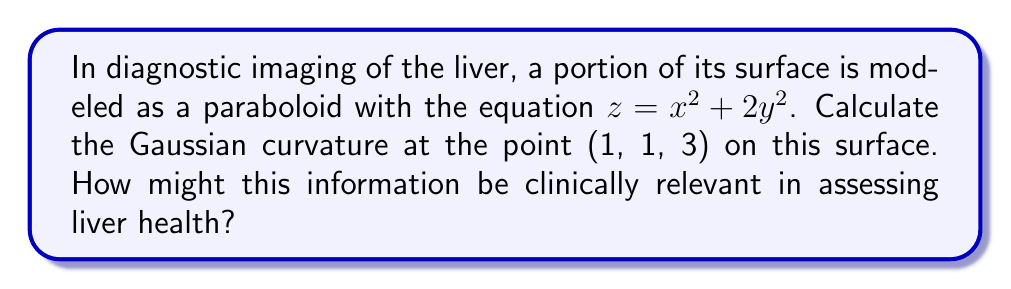Can you solve this math problem? To compute the Gaussian curvature of the liver surface modeled by $z = x^2 + 2y^2$ at the point (1, 1, 3), we'll follow these steps:

1) First, we need to calculate the first and second partial derivatives:
   $f_x = 2x$, $f_y = 4y$
   $f_{xx} = 2$, $f_{yy} = 4$, $f_{xy} = f_{yx} = 0$

2) Next, we compute the coefficients of the first fundamental form:
   $E = 1 + f_x^2 = 1 + 4x^2$
   $F = f_x f_y = 8xy$
   $G = 1 + f_y^2 = 1 + 16y^2$

3) Then, we calculate the coefficients of the second fundamental form:
   $L = \frac{f_{xx}}{\sqrt{1 + f_x^2 + f_y^2}} = \frac{2}{\sqrt{1 + 4x^2 + 16y^2}}$
   $M = \frac{f_{xy}}{\sqrt{1 + f_x^2 + f_y^2}} = 0$
   $N = \frac{f_{yy}}{\sqrt{1 + f_x^2 + f_y^2}} = \frac{4}{\sqrt{1 + 4x^2 + 16y^2}}$

4) The Gaussian curvature K is given by:
   $$K = \frac{LN - M^2}{EG - F^2}$$

5) Substituting the values at the point (1, 1, 3):
   $E = 5$, $G = 17$, $F = 8$
   $L = \frac{2}{\sqrt{21}}$, $N = \frac{4}{\sqrt{21}}$, $M = 0$

6) Computing K:
   $$K = \frac{(\frac{2}{\sqrt{21}})(\frac{4}{\sqrt{21}}) - 0^2}{(5)(17) - 8^2} = \frac{8/21}{85 - 64} = \frac{8/21}{21} = \frac{8}{441}$$

Clinical relevance: The Gaussian curvature provides information about the local shape of the liver surface. Abnormal curvatures could indicate the presence of lesions, tumors, or other structural abnormalities, which may be crucial for early diagnosis and treatment planning in liver diseases.
Answer: $\frac{8}{441}$ 